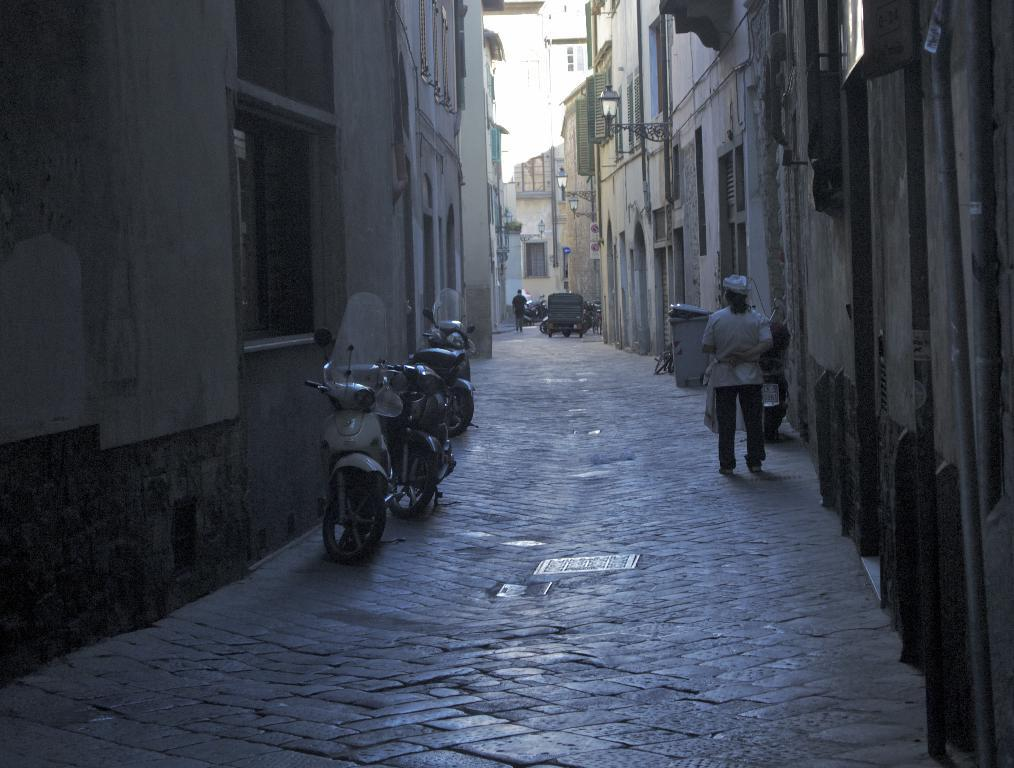What can be seen in the image that people use to travel? There are vehicles around the path in the image. What type of structures are visible near the path? There are buildings around the path in the image. Can you describe the person in the image? There is a person standing on the right side of the image, and they are standing beside a wall. What type of office can be seen in the image? There is no office present in the image. Is the governor visible in the image? There is no governor present in the image. 